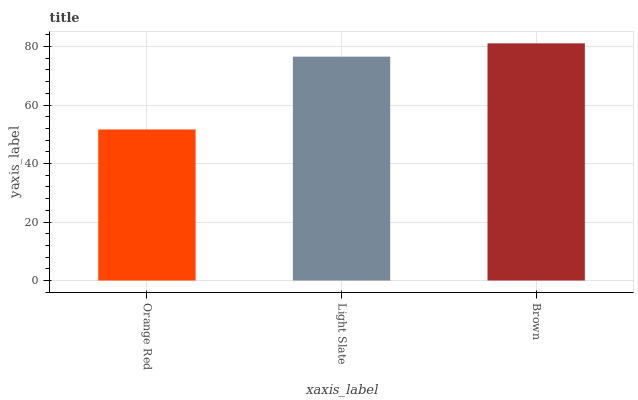Is Orange Red the minimum?
Answer yes or no. Yes. Is Brown the maximum?
Answer yes or no. Yes. Is Light Slate the minimum?
Answer yes or no. No. Is Light Slate the maximum?
Answer yes or no. No. Is Light Slate greater than Orange Red?
Answer yes or no. Yes. Is Orange Red less than Light Slate?
Answer yes or no. Yes. Is Orange Red greater than Light Slate?
Answer yes or no. No. Is Light Slate less than Orange Red?
Answer yes or no. No. Is Light Slate the high median?
Answer yes or no. Yes. Is Light Slate the low median?
Answer yes or no. Yes. Is Orange Red the high median?
Answer yes or no. No. Is Brown the low median?
Answer yes or no. No. 